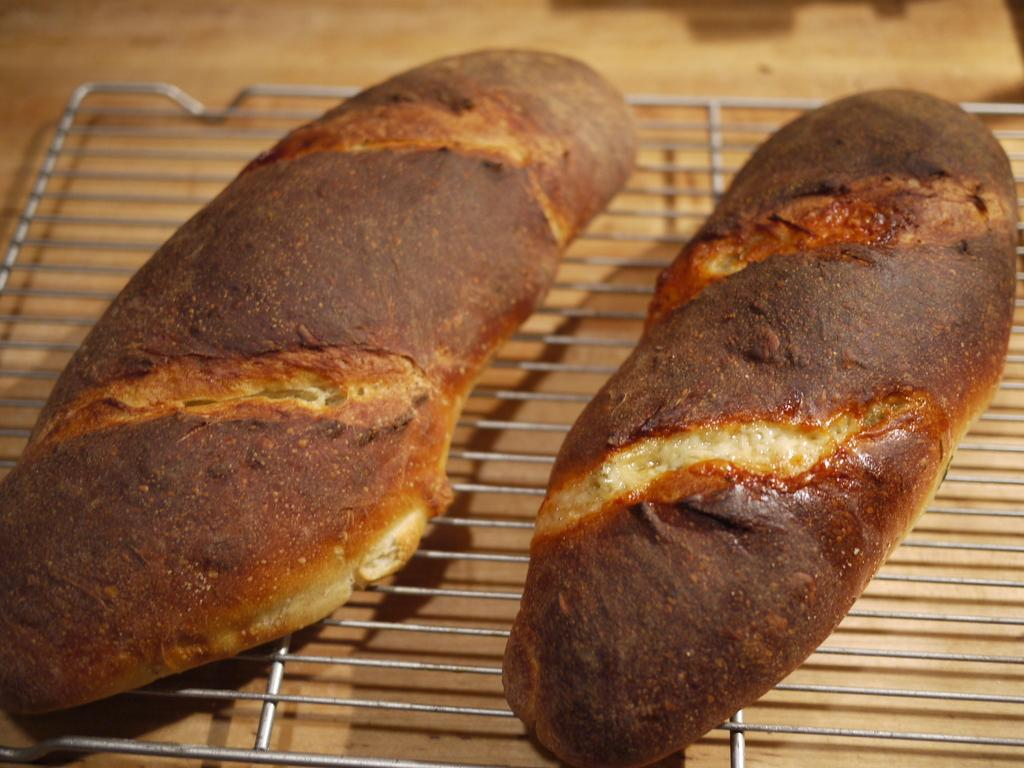What is being cooked in the image? There are food items on a grill in the image. Can you describe the cooking method being used? The food items are being cooked on a grill. What type of food items can be seen on the grill? The specific food items are not mentioned, but they are being cooked on a grill. What type of education can be seen taking place in the cave in the image? There is no cave or education present in the image; it features food items on a grill. 